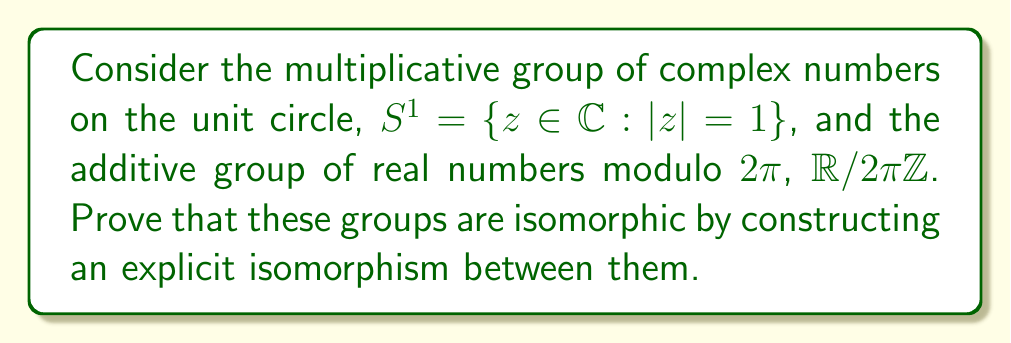Help me with this question. To prove that $S^1$ and $\mathbb{R}/2\pi\mathbb{Z}$ are isomorphic, we need to construct a bijective homomorphism between them. Let's approach this step-by-step:

1) First, let's define a function $f: \mathbb{R}/2\pi\mathbb{Z} \to S^1$ by:

   $f([x]) = e^{ix}$

   where $[x]$ represents the equivalence class of $x$ in $\mathbb{R}/2\pi\mathbb{Z}$.

2) We need to show that $f$ is well-defined. If $[x] = [y]$, then $x - y = 2\pi k$ for some integer $k$. Therefore:

   $e^{ix} = e^{i(y+2\pi k)} = e^{iy}e^{2\pi ik} = e^{iy}$

   So $f$ is indeed well-defined.

3) Next, we need to show that $f$ is a homomorphism. For any $[x], [y] \in \mathbb{R}/2\pi\mathbb{Z}$:

   $f([x] + [y]) = f([x+y]) = e^{i(x+y)} = e^{ix}e^{iy} = f([x])f([y])$

4) To prove that $f$ is injective, suppose $f([x]) = f([y])$. Then:

   $e^{ix} = e^{iy}$
   $e^{i(x-y)} = 1$
   $x - y = 2\pi k$ for some integer $k$
   $[x] = [y]$

5) To prove that $f$ is surjective, take any $z \in S^1$. We can write $z = e^{ix}$ for some $x \in \mathbb{R}$. Then $f([x]) = z$.

6) Since $f$ is a well-defined bijective homomorphism, it is an isomorphism between $\mathbb{R}/2\pi\mathbb{Z}$ and $S^1$.

The inverse isomorphism $g: S^1 \to \mathbb{R}/2\pi\mathbb{Z}$ can be defined as:

$g(e^{ix}) = [x]$

This completes the proof of isomorphism between $S^1$ and $\mathbb{R}/2\pi\mathbb{Z}$.
Answer: The groups $S^1$ and $\mathbb{R}/2\pi\mathbb{Z}$ are isomorphic. An explicit isomorphism $f: \mathbb{R}/2\pi\mathbb{Z} \to S^1$ is given by $f([x]) = e^{ix}$, with inverse $g: S^1 \to \mathbb{R}/2\pi\mathbb{Z}$ given by $g(e^{ix}) = [x]$. 